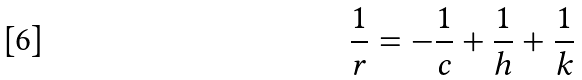<formula> <loc_0><loc_0><loc_500><loc_500>\frac { 1 } { r } = - \frac { 1 } { c } + \frac { 1 } { h } + \frac { 1 } { k }</formula> 